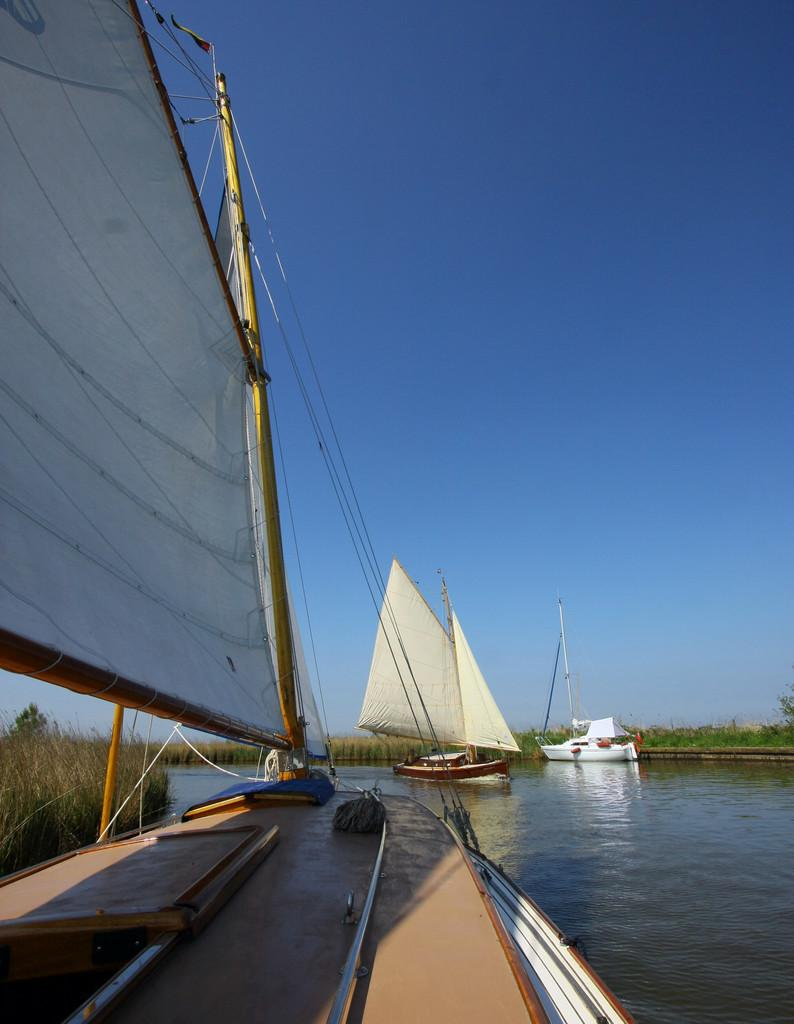What is happening on the water in the image? There are boats sailing on the water in the image. What type of vegetation can be seen in the image? There is grass, plants, and trees visible in the image. What part of the natural environment is visible in the image? The sky is visible in the image. Where is the duck located in the image? There is no duck present in the image. How many people are in the crowd in the image? There is no crowd present in the image. What type of ornament is hanging from the trees in the image? There are no ornaments present in the image; only boats, grass, plants, trees, and the sky are visible. 